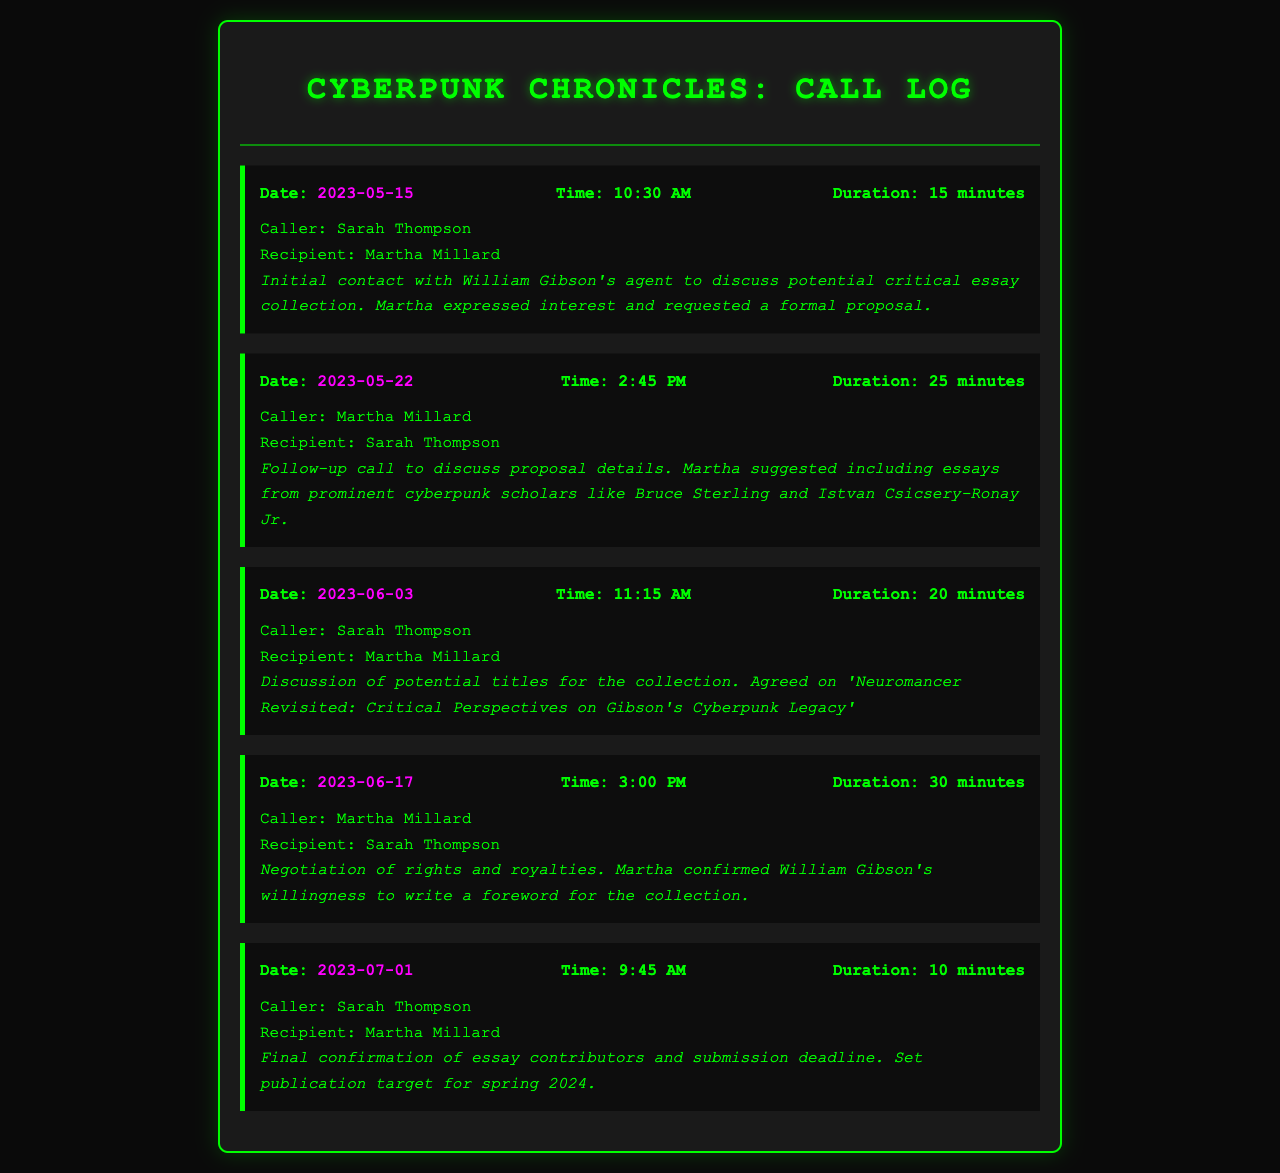What date was the initial contact made? The initial contact occurred on May 15, 2023, as noted in the first call entry.
Answer: May 15, 2023 Who suggested including essays from prominent cyberpunk scholars? The call on May 22, 2023, shows Martha suggested this during the follow-up call.
Answer: Martha What is the title agreed upon for the collection? The title 'Neuromancer Revisited: Critical Perspectives on Gibson's Cyberpunk Legacy' is stated in the call on June 3, 2023.
Answer: Neuromancer Revisited: Critical Perspectives on Gibson's Cyberpunk Legacy How long was the negotiation of rights and royalties call? The duration of the call on June 17, 2023, indicates it lasted for 30 minutes.
Answer: 30 minutes What is the publication target for the collection? According to the final confirmation on July 1, 2023, the publication target is for spring 2024.
Answer: Spring 2024 